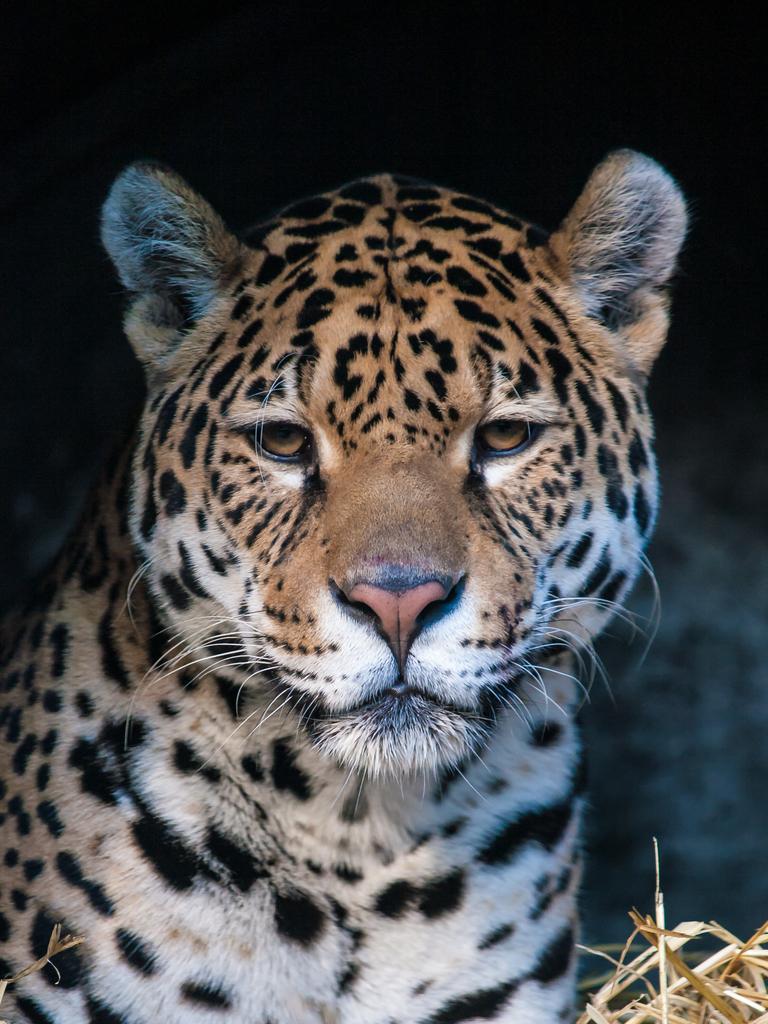Please provide a concise description of this image. Here we can see a tiger and there is a dark background. 